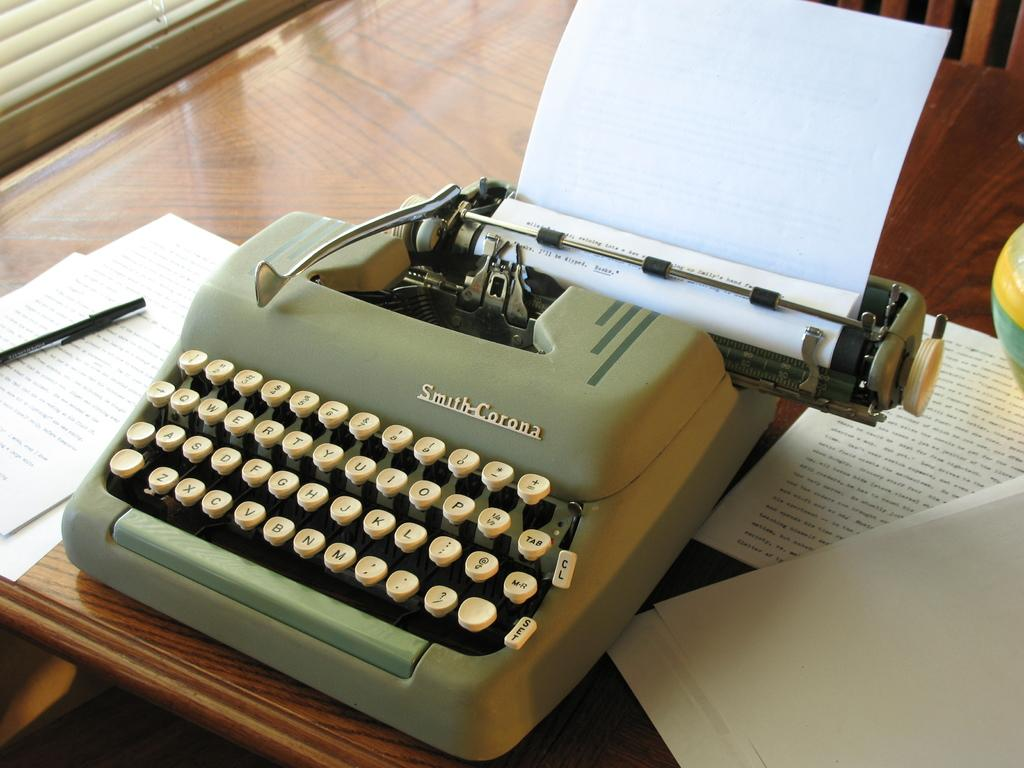<image>
Render a clear and concise summary of the photo. An old type writer from Smith-Corona company is on the table with paper rolled onto it. 